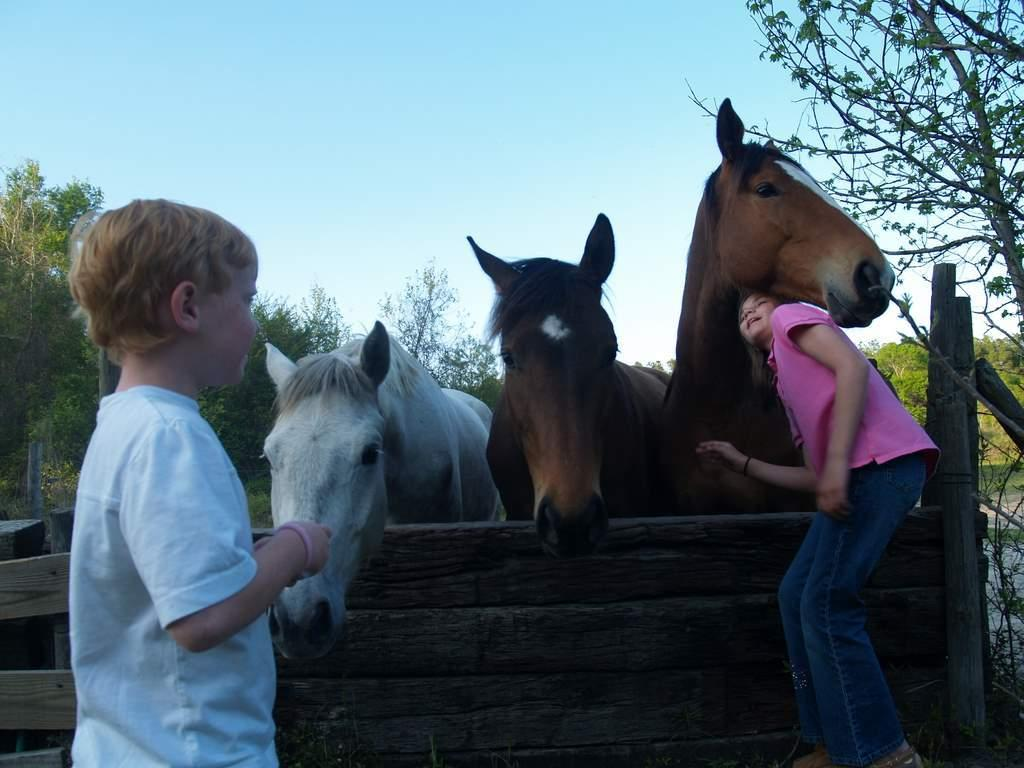Who are the people in the image? There is a boy and a girl in the image. What are the boy and girl doing in the image? The boy and girl are standing near three horses. What can be seen in the background of the image? There are trees and the sky visible in the background of the image. What type of horn can be seen on the head of the girl in the image? There is no horn present on the head of the girl or any of the other subjects in the image. 